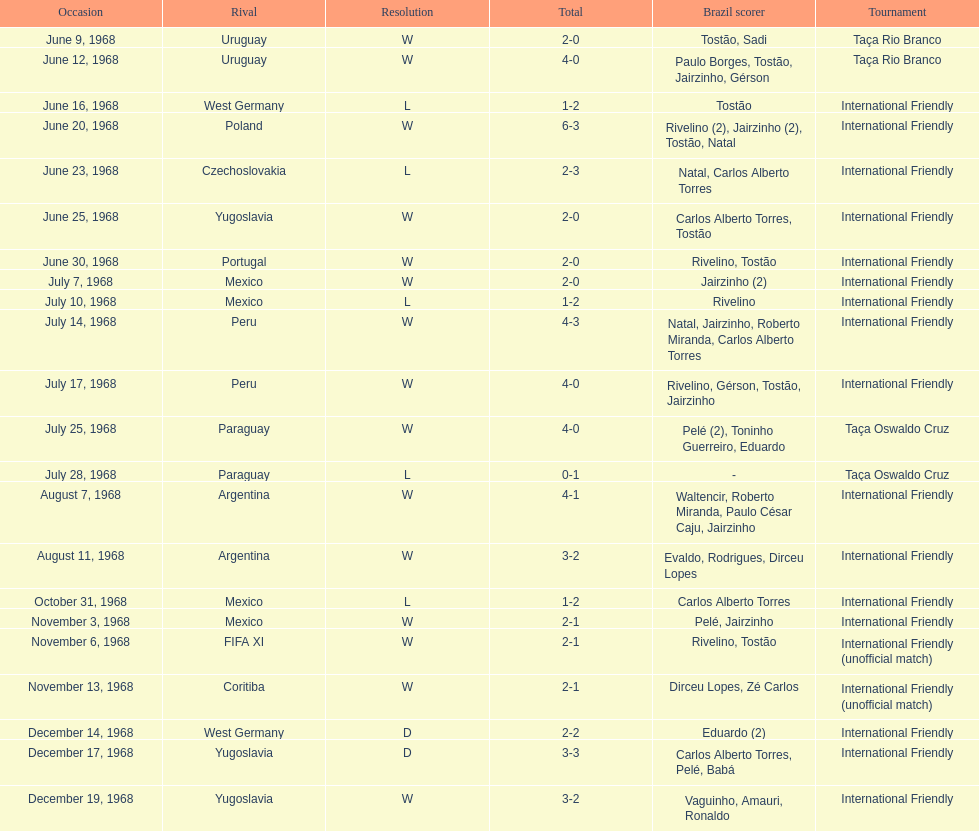The most goals scored by brazil in a game 6. 